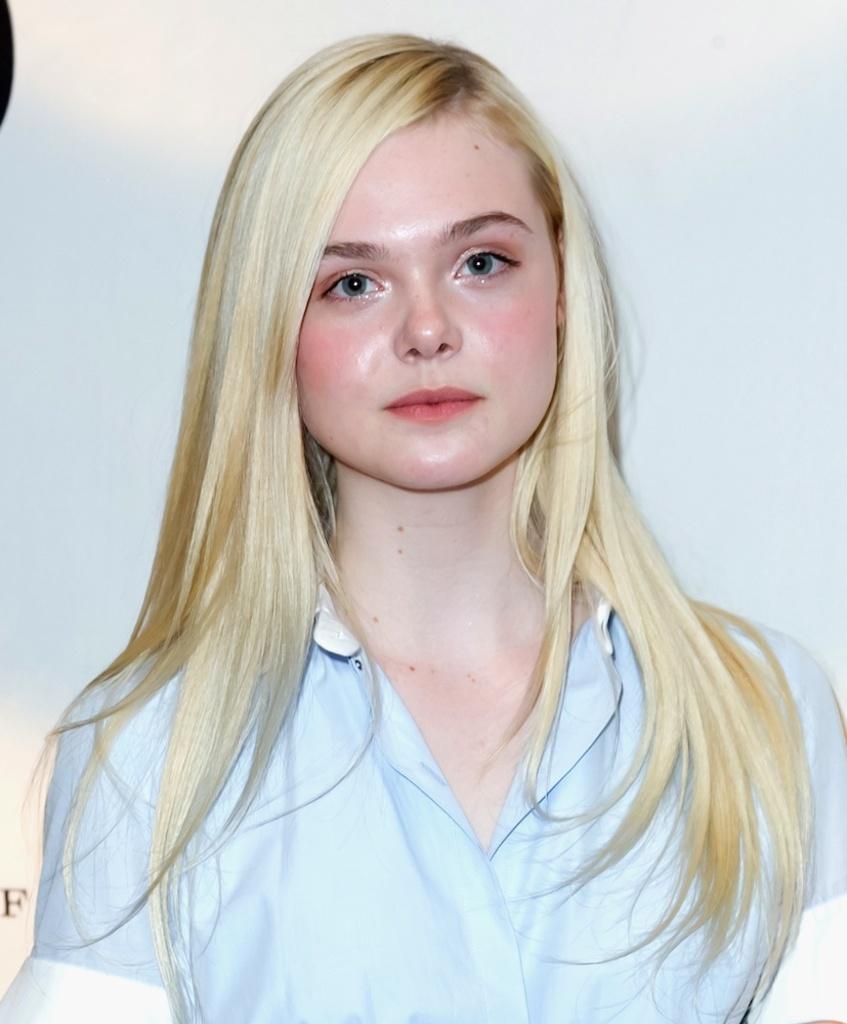Can you describe this image briefly? In this picture there is a girl who is standing in the center of the image. 